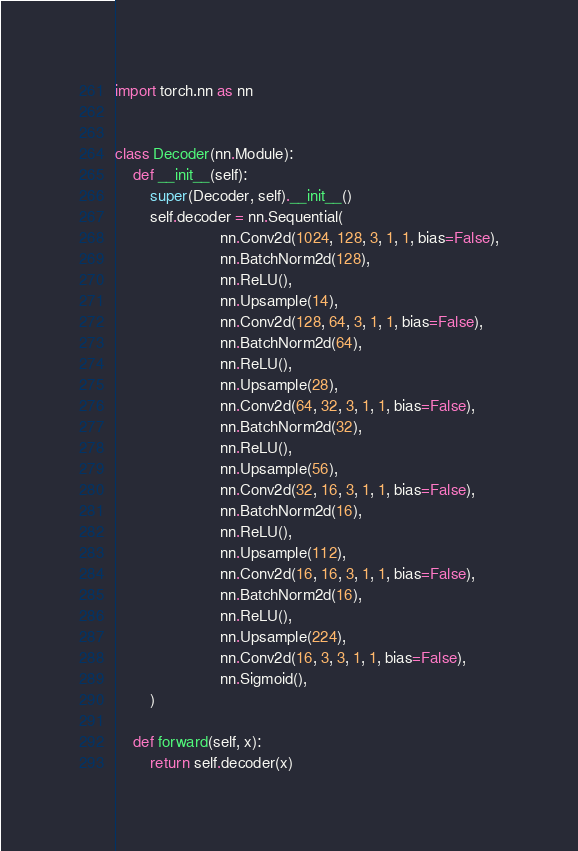Convert code to text. <code><loc_0><loc_0><loc_500><loc_500><_Python_>import torch.nn as nn


class Decoder(nn.Module):
    def __init__(self):
        super(Decoder, self).__init__()
        self.decoder = nn.Sequential(
                        nn.Conv2d(1024, 128, 3, 1, 1, bias=False),
                        nn.BatchNorm2d(128),
                        nn.ReLU(),
                        nn.Upsample(14),
                        nn.Conv2d(128, 64, 3, 1, 1, bias=False),
                        nn.BatchNorm2d(64),
                        nn.ReLU(),
                        nn.Upsample(28),
                        nn.Conv2d(64, 32, 3, 1, 1, bias=False),
                        nn.BatchNorm2d(32),
                        nn.ReLU(),
                        nn.Upsample(56),
                        nn.Conv2d(32, 16, 3, 1, 1, bias=False),
                        nn.BatchNorm2d(16),
                        nn.ReLU(),
                        nn.Upsample(112),
                        nn.Conv2d(16, 16, 3, 1, 1, bias=False),
                        nn.BatchNorm2d(16),
                        nn.ReLU(),
                        nn.Upsample(224),
                        nn.Conv2d(16, 3, 3, 1, 1, bias=False),
                        nn.Sigmoid(),
        )

    def forward(self, x):
        return self.decoder(x)
</code> 